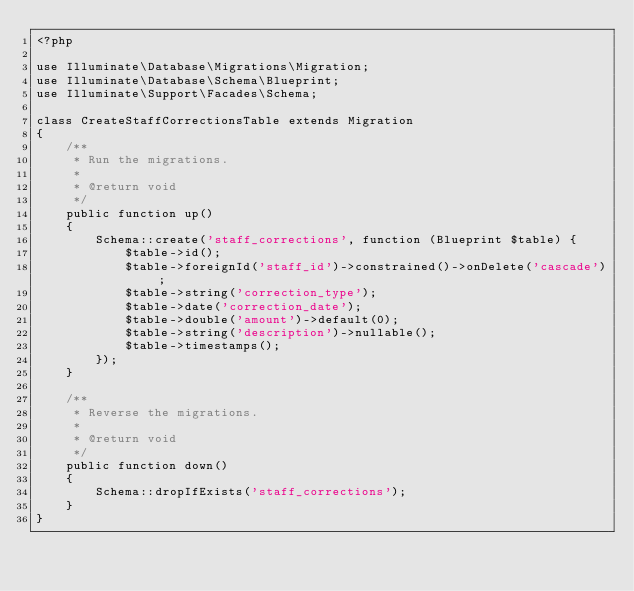<code> <loc_0><loc_0><loc_500><loc_500><_PHP_><?php

use Illuminate\Database\Migrations\Migration;
use Illuminate\Database\Schema\Blueprint;
use Illuminate\Support\Facades\Schema;

class CreateStaffCorrectionsTable extends Migration
{
    /**
     * Run the migrations.
     *
     * @return void
     */
    public function up()
    {
        Schema::create('staff_corrections', function (Blueprint $table) {
            $table->id();
            $table->foreignId('staff_id')->constrained()->onDelete('cascade');
            $table->string('correction_type');
            $table->date('correction_date');
            $table->double('amount')->default(0);
            $table->string('description')->nullable();
            $table->timestamps();
        });
    }

    /**
     * Reverse the migrations.
     *
     * @return void
     */
    public function down()
    {
        Schema::dropIfExists('staff_corrections');
    }
}
</code> 